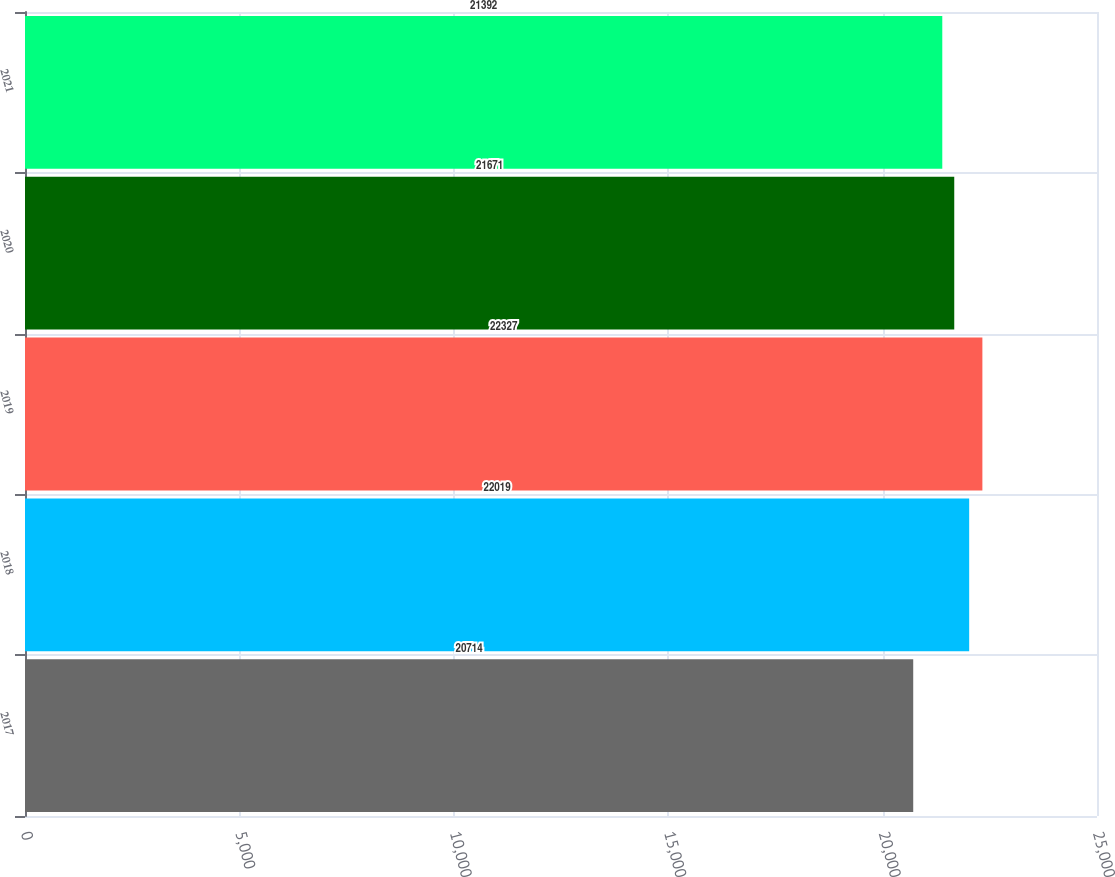Convert chart to OTSL. <chart><loc_0><loc_0><loc_500><loc_500><bar_chart><fcel>2017<fcel>2018<fcel>2019<fcel>2020<fcel>2021<nl><fcel>20714<fcel>22019<fcel>22327<fcel>21671<fcel>21392<nl></chart> 